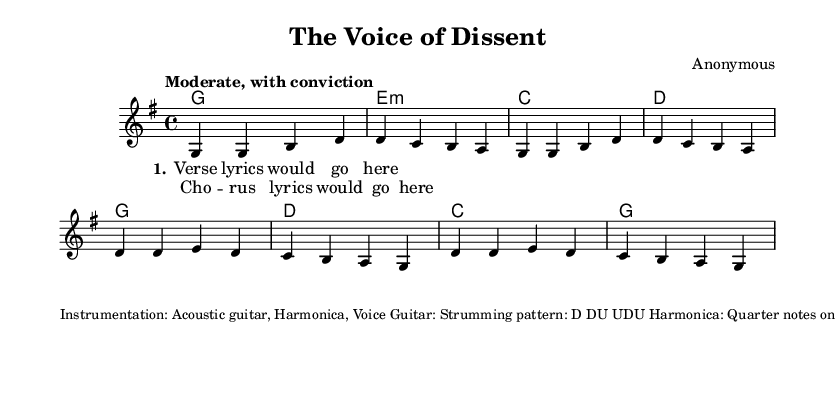What is the key signature of this music? The key signature is G major, which contains one sharp (F#). This is evident in the section of the sheet music that indicates the key signature at the beginning.
Answer: G major What is the time signature of this music? The time signature is 4/4, which is indicated at the beginning of the sheet music. This means there are four beats in a measure and the quarter note receives one beat.
Answer: 4/4 What is the tempo indication of this music? The tempo is marked as "Moderate, with conviction," which suggests a steady and confident pace. This is stated explicitly in the introductory section of the sheet music.
Answer: Moderate, with conviction How many verses are indicated in the song structure? The structure includes two verses as mentioned in the breakdown provided at the end of the sheet music. It is outlined as "Verse 1" and "Verse 2."
Answer: 2 What is the prominent theme of this song? The theme addresses the need for better support for veterans, criticizing current policies and calling for change. This is a central point discussed in the music's conclusion and purpose statement.
Answer: Support for veterans What instrumentation is used in this song? The song features an acoustic guitar, harmonica, and voice, as outlined in the notes at the bottom of the sheet music. This gives insight into how the music is performed.
Answer: Acoustic guitar, harmonica, voice What is the strumming pattern for the guitar? The strumming pattern for the guitar is indicated as "D DU UDU". This is found in the section detailing instrumentation and performance instructions.
Answer: D DU UDU 